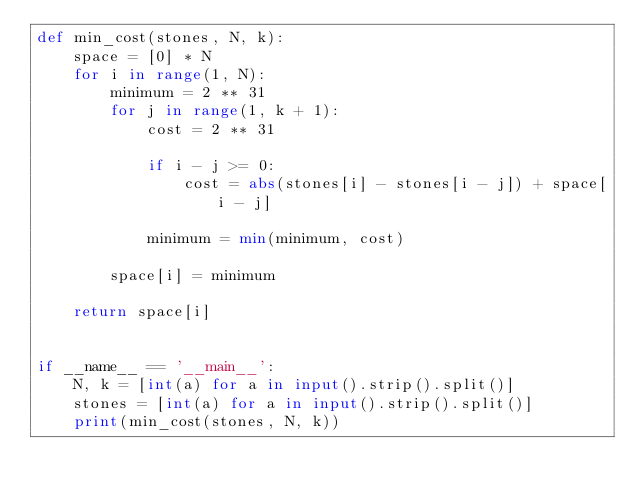Convert code to text. <code><loc_0><loc_0><loc_500><loc_500><_Python_>def min_cost(stones, N, k):
    space = [0] * N
    for i in range(1, N):
        minimum = 2 ** 31
        for j in range(1, k + 1):
            cost = 2 ** 31

            if i - j >= 0:
                cost = abs(stones[i] - stones[i - j]) + space[i - j]

            minimum = min(minimum, cost)

        space[i] = minimum

    return space[i]


if __name__ == '__main__':
    N, k = [int(a) for a in input().strip().split()]
    stones = [int(a) for a in input().strip().split()]
    print(min_cost(stones, N, k))

</code> 